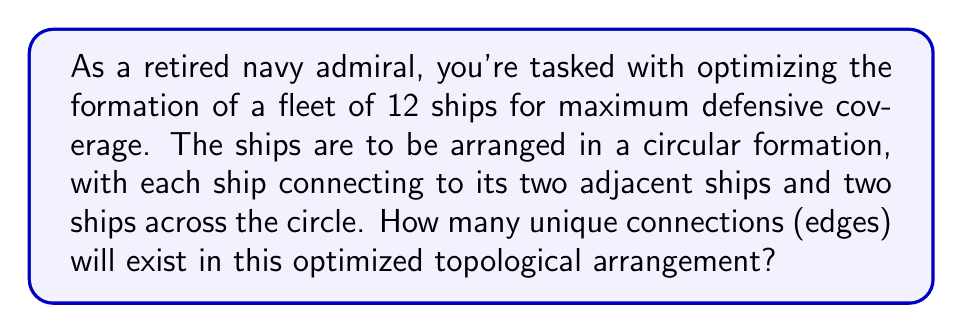Provide a solution to this math problem. Let's approach this step-by-step:

1) First, we need to understand the topological structure we're dealing with. This is a circular graph where each node (ship) is connected to 4 other nodes.

2) In graph theory, this structure is known as a circulant graph. Specifically, it's a C(12,1,2) circulant graph, where 12 is the number of nodes, and 1 and 2 represent the connection patterns.

3) To calculate the number of edges, we can use the formula for the number of edges in a circulant graph:

   $$|E| = \frac{n \cdot k}{2}$$

   Where $n$ is the number of nodes and $k$ is the degree of each node (number of connections per node).

4) In this case:
   $n = 12$ (number of ships)
   $k = 4$ (each ship connects to 4 others)

5) Plugging these values into our formula:

   $$|E| = \frac{12 \cdot 4}{2} = \frac{48}{2} = 24$$

6) However, this counts each connection twice (once from each end), so we need to divide by 2:

   $$\text{Number of unique connections} = \frac{24}{2} = 12$$

This result can be verified by visualizing the arrangement and counting the unique connections.

[asy]
unitsize(2cm);
int n = 12;
for(int i=0; i<n; ++i) {
  dot((cos(2pi*i/n), sin(2pi*i/n)));
  draw((cos(2pi*i/n), sin(2pi*i/n))--(cos(2pi*((i+1)%n)/n), sin(2pi*((i+1)%n)/n)), blue);
  draw((cos(2pi*i/n), sin(2pi*i/n))--(cos(2pi*((i+2)%n)/n), sin(2pi*((i+2)%n)/n)), red);
}
[/asy]
Answer: The optimized topological arrangement will have 24 unique connections (edges). 